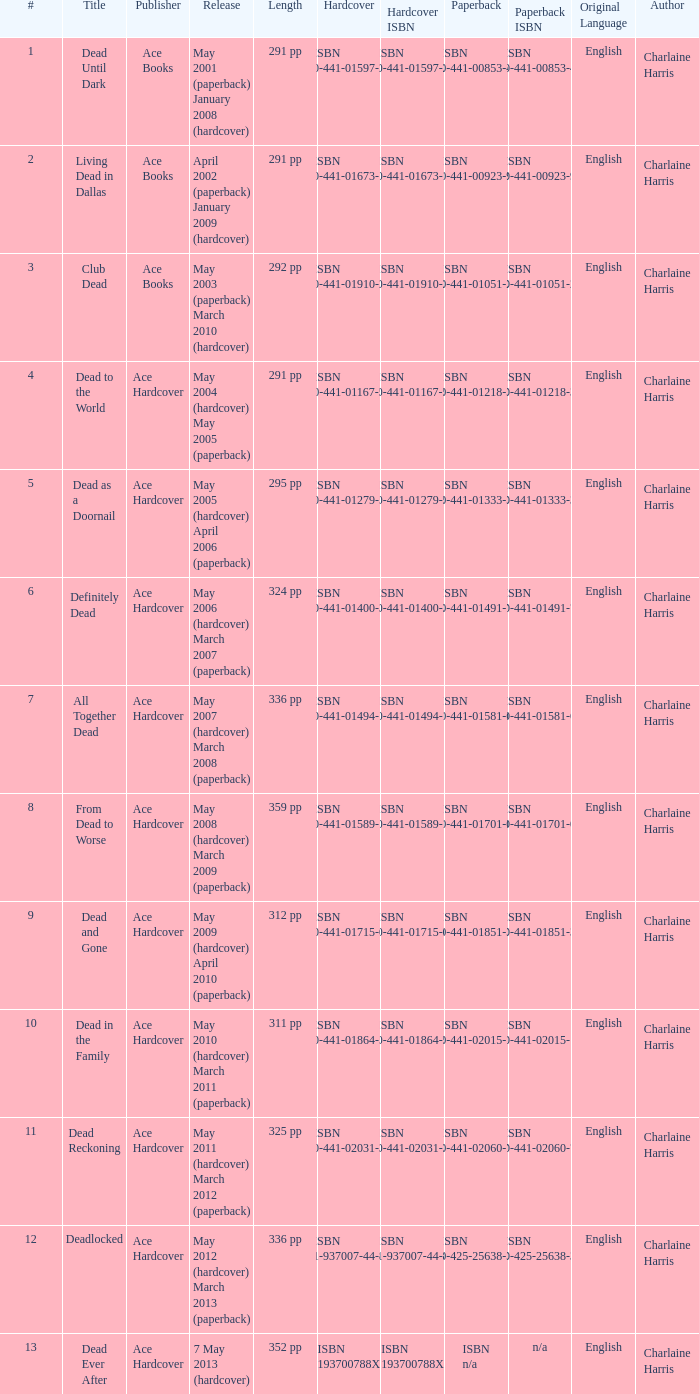How many publishers put out isbn 193700788x? 1.0. 